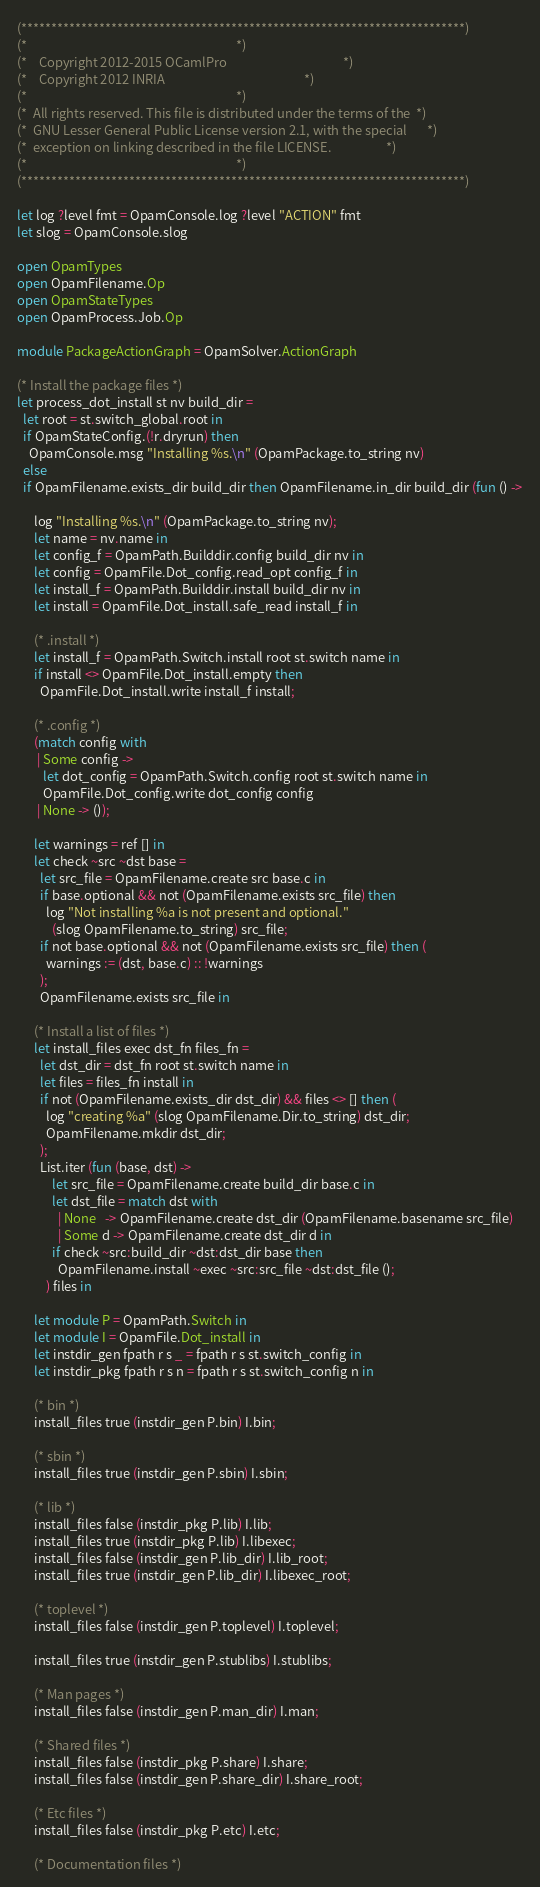<code> <loc_0><loc_0><loc_500><loc_500><_OCaml_>(**************************************************************************)
(*                                                                        *)
(*    Copyright 2012-2015 OCamlPro                                        *)
(*    Copyright 2012 INRIA                                                *)
(*                                                                        *)
(*  All rights reserved. This file is distributed under the terms of the  *)
(*  GNU Lesser General Public License version 2.1, with the special       *)
(*  exception on linking described in the file LICENSE.                   *)
(*                                                                        *)
(**************************************************************************)

let log ?level fmt = OpamConsole.log ?level "ACTION" fmt
let slog = OpamConsole.slog

open OpamTypes
open OpamFilename.Op
open OpamStateTypes
open OpamProcess.Job.Op

module PackageActionGraph = OpamSolver.ActionGraph

(* Install the package files *)
let process_dot_install st nv build_dir =
  let root = st.switch_global.root in
  if OpamStateConfig.(!r.dryrun) then
    OpamConsole.msg "Installing %s.\n" (OpamPackage.to_string nv)
  else
  if OpamFilename.exists_dir build_dir then OpamFilename.in_dir build_dir (fun () ->

      log "Installing %s.\n" (OpamPackage.to_string nv);
      let name = nv.name in
      let config_f = OpamPath.Builddir.config build_dir nv in
      let config = OpamFile.Dot_config.read_opt config_f in
      let install_f = OpamPath.Builddir.install build_dir nv in
      let install = OpamFile.Dot_install.safe_read install_f in

      (* .install *)
      let install_f = OpamPath.Switch.install root st.switch name in
      if install <> OpamFile.Dot_install.empty then
        OpamFile.Dot_install.write install_f install;

      (* .config *)
      (match config with
       | Some config ->
         let dot_config = OpamPath.Switch.config root st.switch name in
         OpamFile.Dot_config.write dot_config config
       | None -> ());

      let warnings = ref [] in
      let check ~src ~dst base =
        let src_file = OpamFilename.create src base.c in
        if base.optional && not (OpamFilename.exists src_file) then
          log "Not installing %a is not present and optional."
            (slog OpamFilename.to_string) src_file;
        if not base.optional && not (OpamFilename.exists src_file) then (
          warnings := (dst, base.c) :: !warnings
        );
        OpamFilename.exists src_file in

      (* Install a list of files *)
      let install_files exec dst_fn files_fn =
        let dst_dir = dst_fn root st.switch name in
        let files = files_fn install in
        if not (OpamFilename.exists_dir dst_dir) && files <> [] then (
          log "creating %a" (slog OpamFilename.Dir.to_string) dst_dir;
          OpamFilename.mkdir dst_dir;
        );
        List.iter (fun (base, dst) ->
            let src_file = OpamFilename.create build_dir base.c in
            let dst_file = match dst with
              | None   -> OpamFilename.create dst_dir (OpamFilename.basename src_file)
              | Some d -> OpamFilename.create dst_dir d in
            if check ~src:build_dir ~dst:dst_dir base then
              OpamFilename.install ~exec ~src:src_file ~dst:dst_file ();
          ) files in

      let module P = OpamPath.Switch in
      let module I = OpamFile.Dot_install in
      let instdir_gen fpath r s _ = fpath r s st.switch_config in
      let instdir_pkg fpath r s n = fpath r s st.switch_config n in

      (* bin *)
      install_files true (instdir_gen P.bin) I.bin;

      (* sbin *)
      install_files true (instdir_gen P.sbin) I.sbin;

      (* lib *)
      install_files false (instdir_pkg P.lib) I.lib;
      install_files true (instdir_pkg P.lib) I.libexec;
      install_files false (instdir_gen P.lib_dir) I.lib_root;
      install_files true (instdir_gen P.lib_dir) I.libexec_root;

      (* toplevel *)
      install_files false (instdir_gen P.toplevel) I.toplevel;

      install_files true (instdir_gen P.stublibs) I.stublibs;

      (* Man pages *)
      install_files false (instdir_gen P.man_dir) I.man;

      (* Shared files *)
      install_files false (instdir_pkg P.share) I.share;
      install_files false (instdir_gen P.share_dir) I.share_root;

      (* Etc files *)
      install_files false (instdir_pkg P.etc) I.etc;

      (* Documentation files *)</code> 